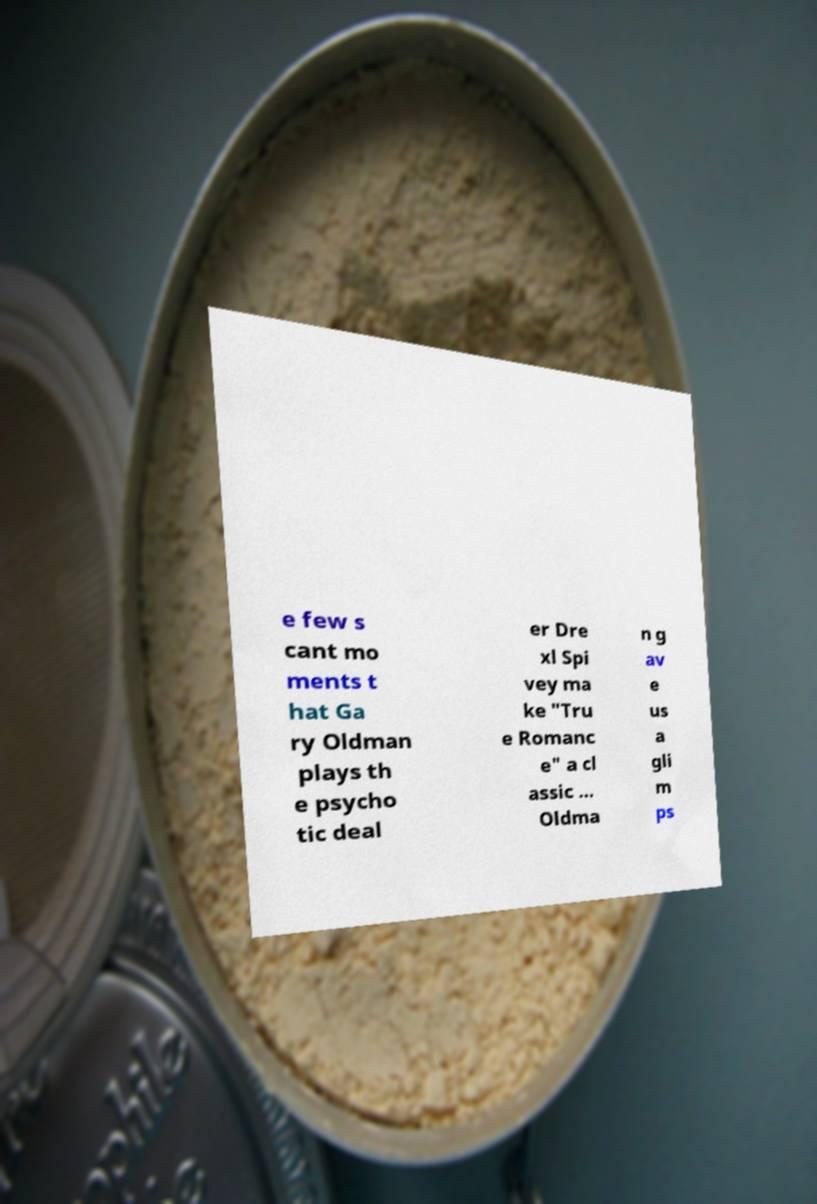Please identify and transcribe the text found in this image. e few s cant mo ments t hat Ga ry Oldman plays th e psycho tic deal er Dre xl Spi vey ma ke "Tru e Romanc e" a cl assic ... Oldma n g av e us a gli m ps 